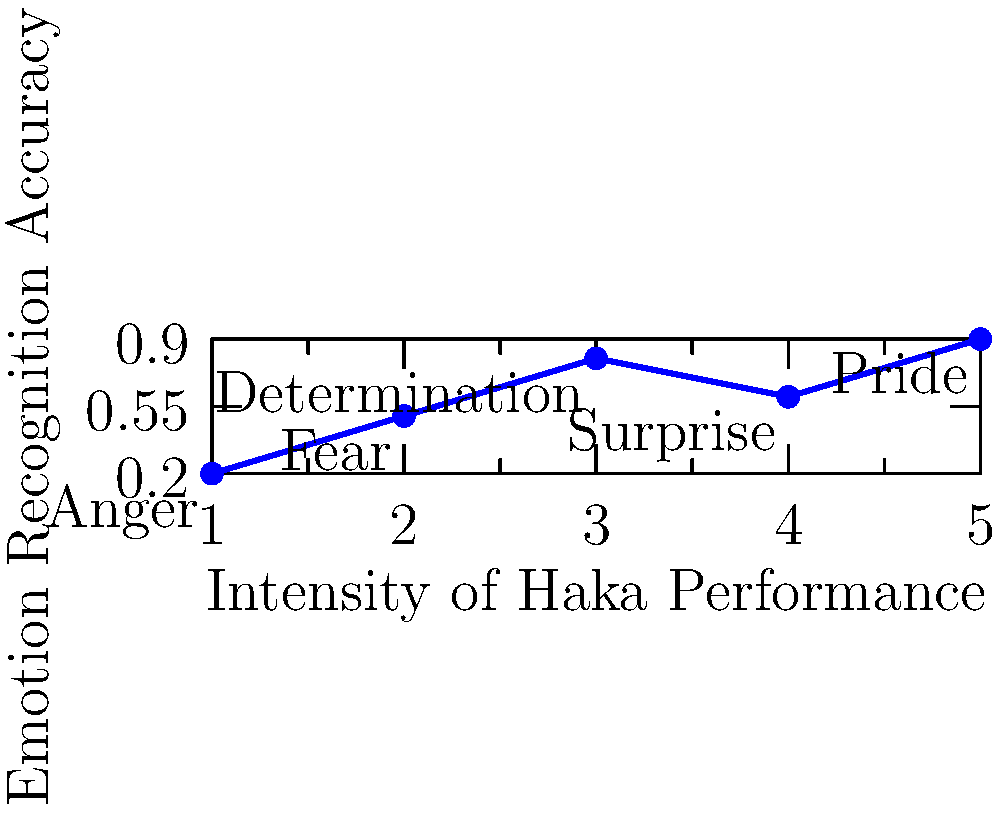In a study on emotion recognition during Maori haka performances, researchers analyzed facial expressions at different intensity levels. Based on the graph, which emotion showed the highest recognition accuracy, and how might this relate to the cultural significance of haka? To answer this question, we need to analyze the graph and understand the cultural context of haka:

1. The x-axis represents the intensity of the haka performance, while the y-axis shows the emotion recognition accuracy.

2. Each point on the graph represents a different emotion:
   - (1, 0.2): Anger
   - (2, 0.5): Fear
   - (3, 0.8): Determination
   - (4, 0.6): Surprise
   - (5, 0.9): Pride

3. The highest point on the graph corresponds to Pride at (5, 0.9), indicating the highest recognition accuracy.

4. Cultural significance:
   - Haka is a traditional Maori war dance or challenge.
   - It is often performed to demonstrate tribal pride, unity, and strength.
   - The high recognition accuracy for pride aligns with the cultural importance of haka as an expression of Maori identity and heritage.

5. The intensity level (5) for pride suggests that pride becomes more evident and recognizable as the performance intensifies, which is consistent with the passionate and powerful nature of haka.

6. This finding highlights the effectiveness of haka in conveying pride, a crucial emotion in Maori cultural expressions.
Answer: Pride, aligning with haka's cultural role in expressing Maori identity and strength. 